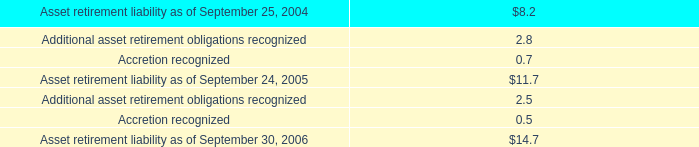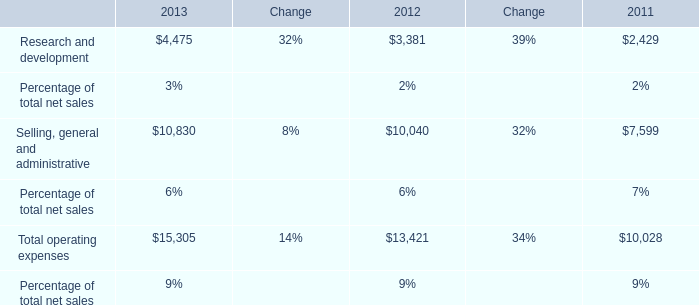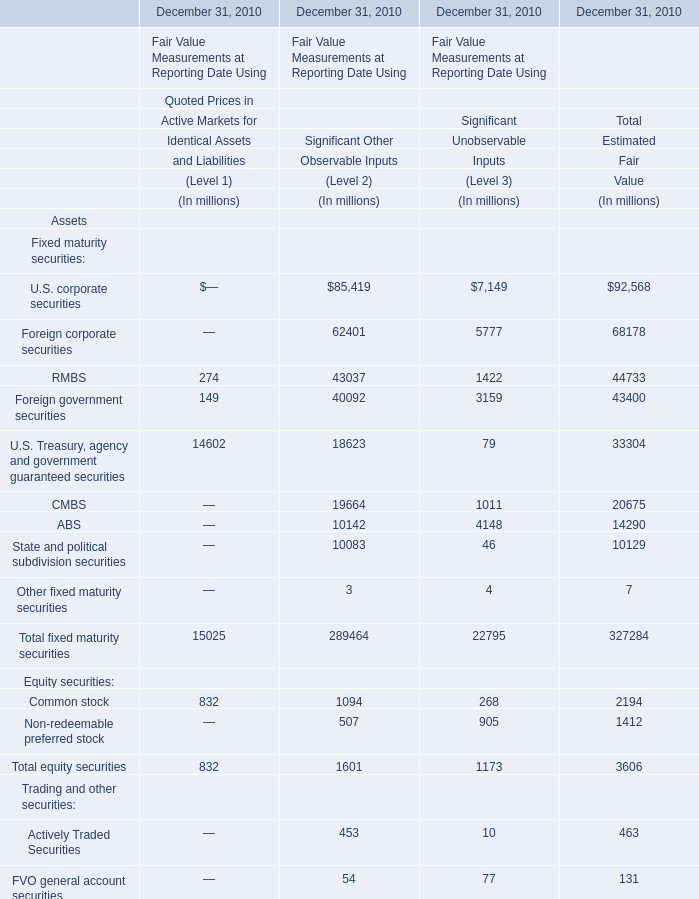What is the sum of Fixed maturity securities in total estimated fair value? (in million) 
Computations: ((((((((92568 + 68178) + 44733) + 43400) + 33304) + 20675) + 14290) + 10129) + 7)
Answer: 327284.0. 